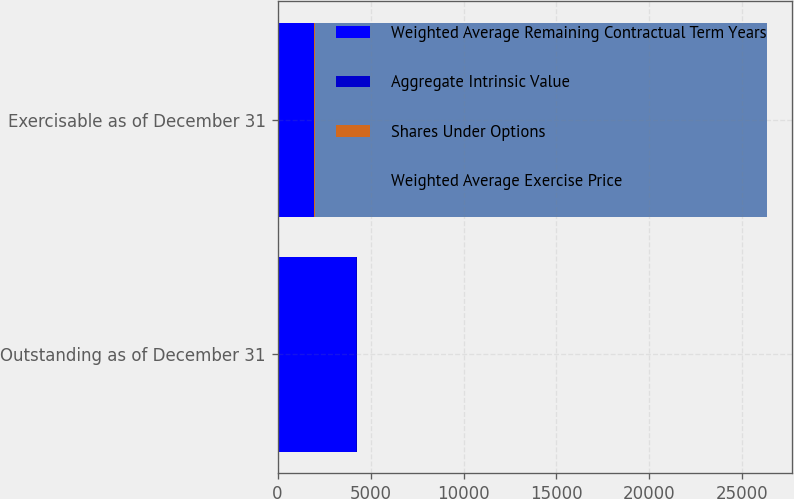Convert chart. <chart><loc_0><loc_0><loc_500><loc_500><stacked_bar_chart><ecel><fcel>Outstanding as of December 31<fcel>Exercisable as of December 31<nl><fcel>Weighted Average Remaining Contractual Term Years<fcel>4236<fcel>1959<nl><fcel>Aggregate Intrinsic Value<fcel>26.25<fcel>22.47<nl><fcel>Shares Under Options<fcel>6.7<fcel>5.4<nl><fcel>Weighted Average Exercise Price<fcel>26.25<fcel>24362<nl></chart> 